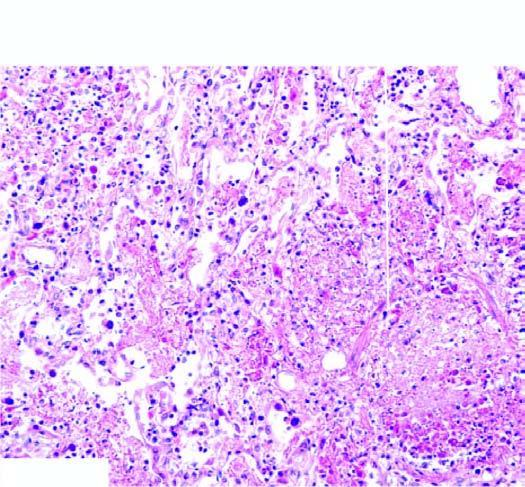s there interstitial inflammation?
Answer the question using a single word or phrase. Yes 